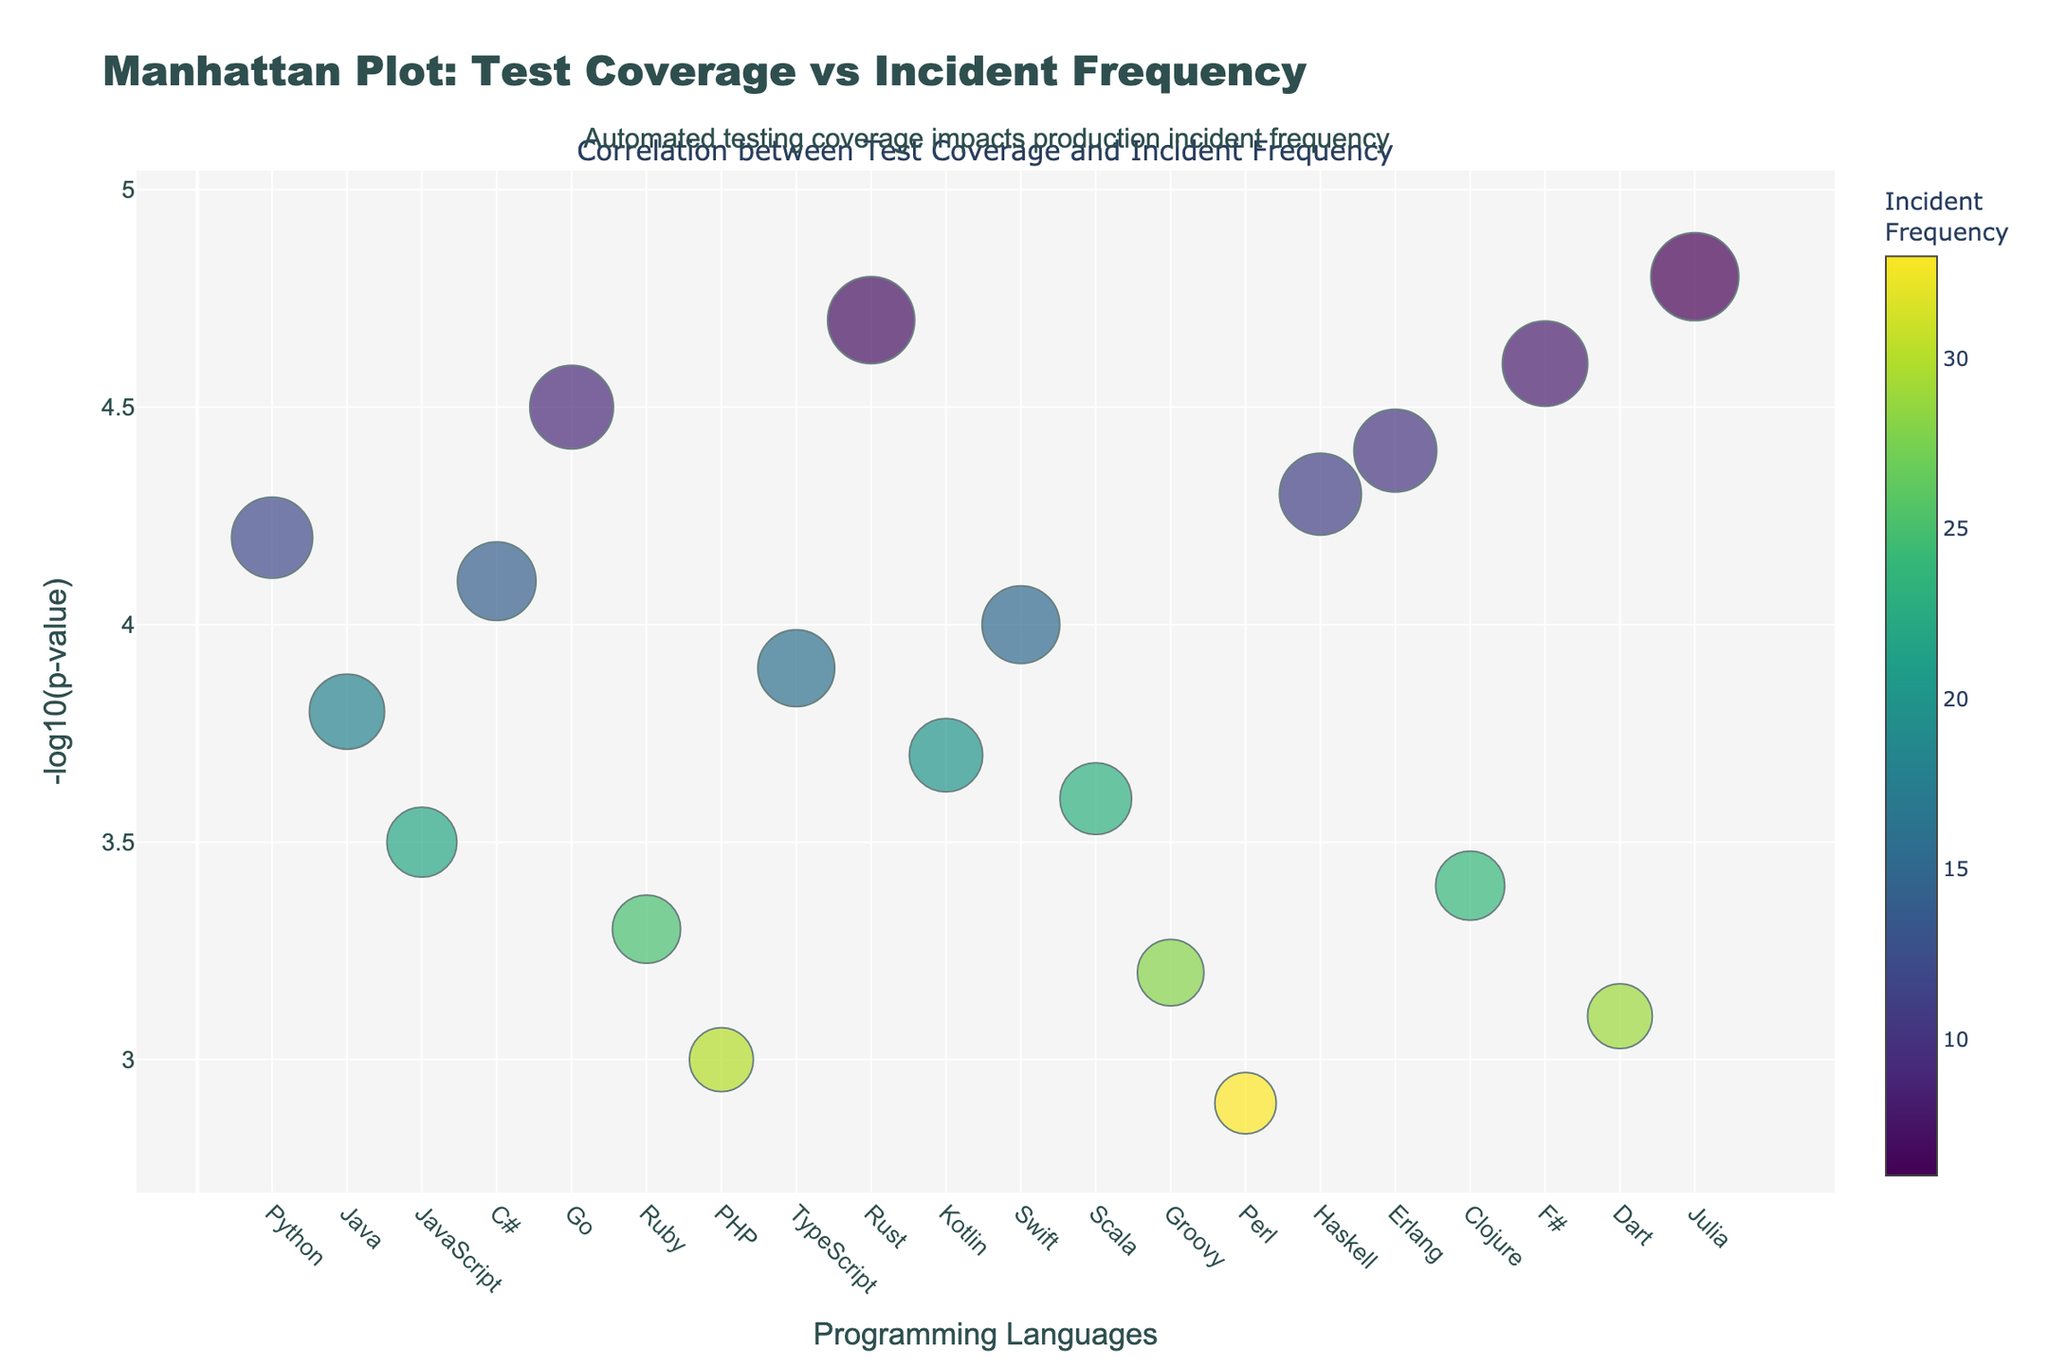What does the title of the figure say? The title of the figure can be found at the top. It reads: "Manhattan Plot: Test Coverage vs Incident Frequency"
Answer: "Manhattan Plot: Test Coverage vs Incident Frequency" What is represented on the x-axis of the figure? On the x-axis, the figure shows different programming languages. These include Python, Java, JavaScript, C#, Go, Ruby, PHP, TypeScript, Rust, Kotlin, Swift, Scala, Groovy, Perl, Haskell, Erlang, Clojure, F#, Dart, and Julia.
Answer: Programming languages What is the meaning of the y-axis in the figure? The y-axis displays the -log10(p-value). This indicates the strength of the correlation between automated testing coverage and production incident frequency for each programming language.
Answer: -log10(p-value) Which programming language has the highest test coverage? To determine the programming language with the highest test coverage, we look at the size of the points on the plot. Rust has the largest point size, implying the highest test coverage.
Answer: Rust Which programming language has the highest production incident frequency? The language with the highest production incident frequency is represented by the darkest color in the color gradient. Perl has the darkest color, indicating the highest number of incidents.
Answer: Perl How many languages have a -log10(p-value) greater than 4? Look at the y-axis and count the number of points above the 4 mark. There are six languages with -log10(p-value) greater than 4: Python, C#, Go, Rust, Haskell, Erlang, Julia, and F#.
Answer: 8 Which programming language has the least number of production incidents and how many? The programming language with the least number of production incidents can be identified by the lightest color in the color gradient. Julia has the lightest color, indicating it has the fewest incidents. According to the legend, Julia has 6 incidents.
Answer: Julia, 6 Compare test coverage of Python and Java. Which one has higher coverage and by how much percentage? To compare the test coverage, look at the size of the points for Python and Java. Python has a test coverage size equivalent to 85%, while Java's is 78%. The difference is 85 - 78 = 7%.
Answer: Python, 7% What does a larger point size represent in the figure? Larger point sizes represent higher test coverage percentages for the corresponding programming language. This is deduced from the detailed hover text that indicates the test coverage information.
Answer: Higher test coverage Explain how the color scale is used to represent the data in the figure. The color scale represents the frequency of production incidents. Darker colors indicate higher incident frequencies, while lighter colors indicate lower frequencies. Each point's color intensity correlates with the number of incidents.
Answer: Darker colors indicate higher incident frequencies, lighter colors indicate lower How does automated testing coverage impact the incident frequencies generally in this plot? From the plot, it seems that languages with higher test coverage tend to have lower incident frequencies, illustrated by the inverse relationship where larger point sizes (higher coverage) tend to be lighter in color (fewer incidents).
Answer: Higher coverage generally leads to fewer incidents 